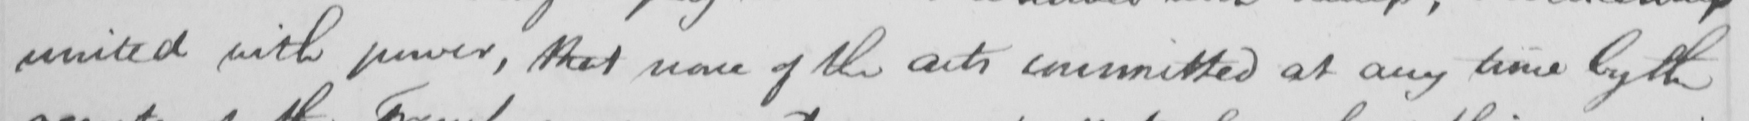Can you read and transcribe this handwriting? united with power , that none of the acts committed at any time by the 